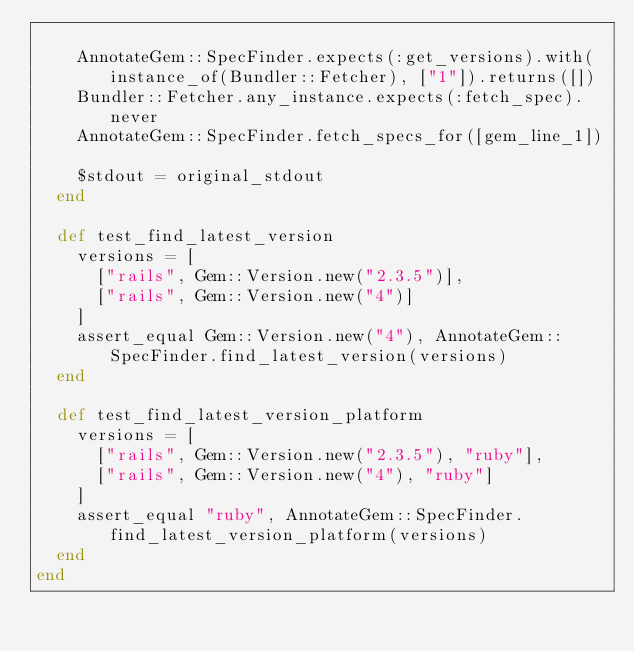<code> <loc_0><loc_0><loc_500><loc_500><_Ruby_>
    AnnotateGem::SpecFinder.expects(:get_versions).with(instance_of(Bundler::Fetcher), ["1"]).returns([])
    Bundler::Fetcher.any_instance.expects(:fetch_spec).never
    AnnotateGem::SpecFinder.fetch_specs_for([gem_line_1])

    $stdout = original_stdout
  end

  def test_find_latest_version
    versions = [
      ["rails", Gem::Version.new("2.3.5")],
      ["rails", Gem::Version.new("4")]
    ]
    assert_equal Gem::Version.new("4"), AnnotateGem::SpecFinder.find_latest_version(versions)
  end

  def test_find_latest_version_platform
    versions = [
      ["rails", Gem::Version.new("2.3.5"), "ruby"],
      ["rails", Gem::Version.new("4"), "ruby"]
    ]
    assert_equal "ruby", AnnotateGem::SpecFinder.find_latest_version_platform(versions)
  end
end
</code> 